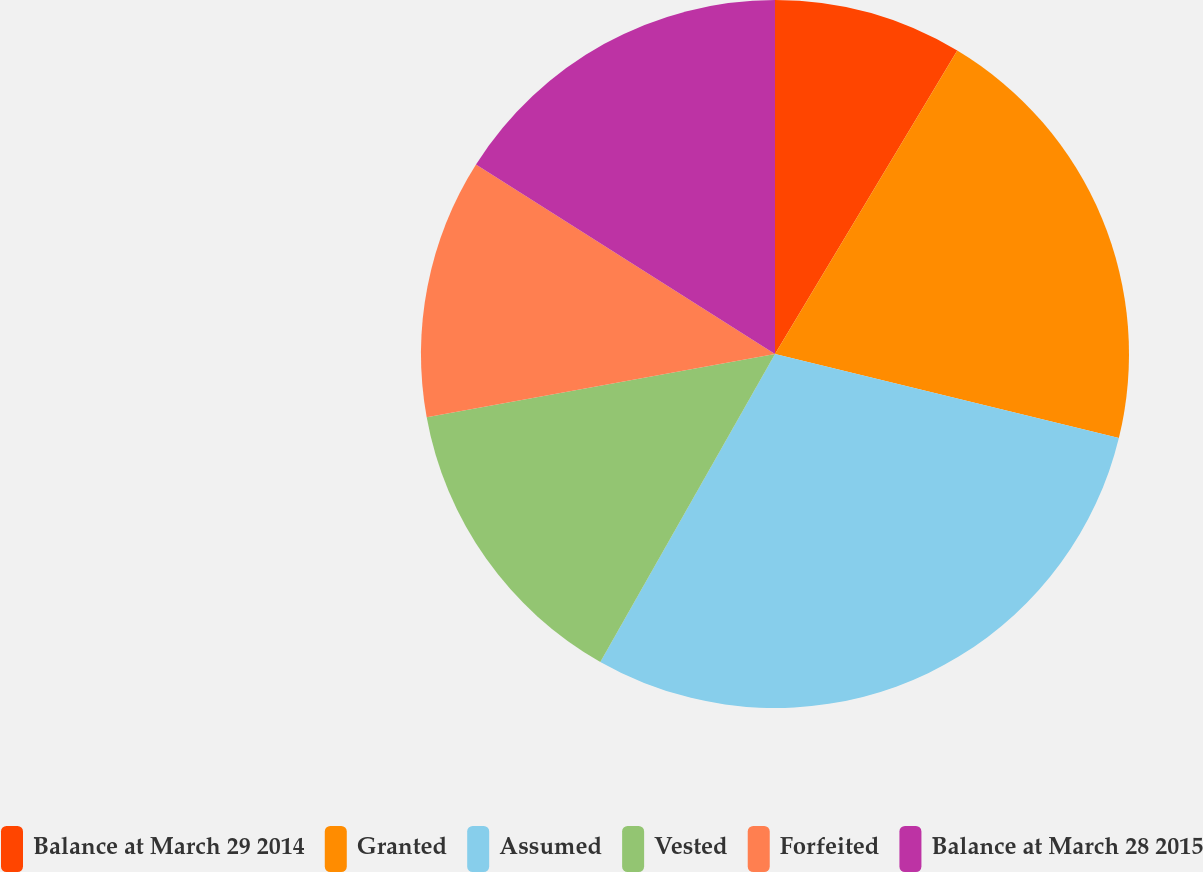Convert chart. <chart><loc_0><loc_0><loc_500><loc_500><pie_chart><fcel>Balance at March 29 2014<fcel>Granted<fcel>Assumed<fcel>Vested<fcel>Forfeited<fcel>Balance at March 28 2015<nl><fcel>8.61%<fcel>20.21%<fcel>29.4%<fcel>13.93%<fcel>11.85%<fcel>16.01%<nl></chart> 